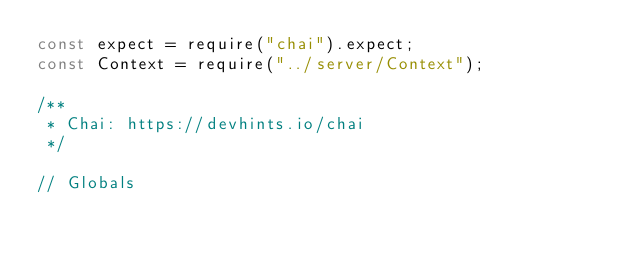<code> <loc_0><loc_0><loc_500><loc_500><_JavaScript_>const expect = require("chai").expect;
const Context = require("../server/Context");

/**
 * Chai: https://devhints.io/chai
 */

// Globals</code> 